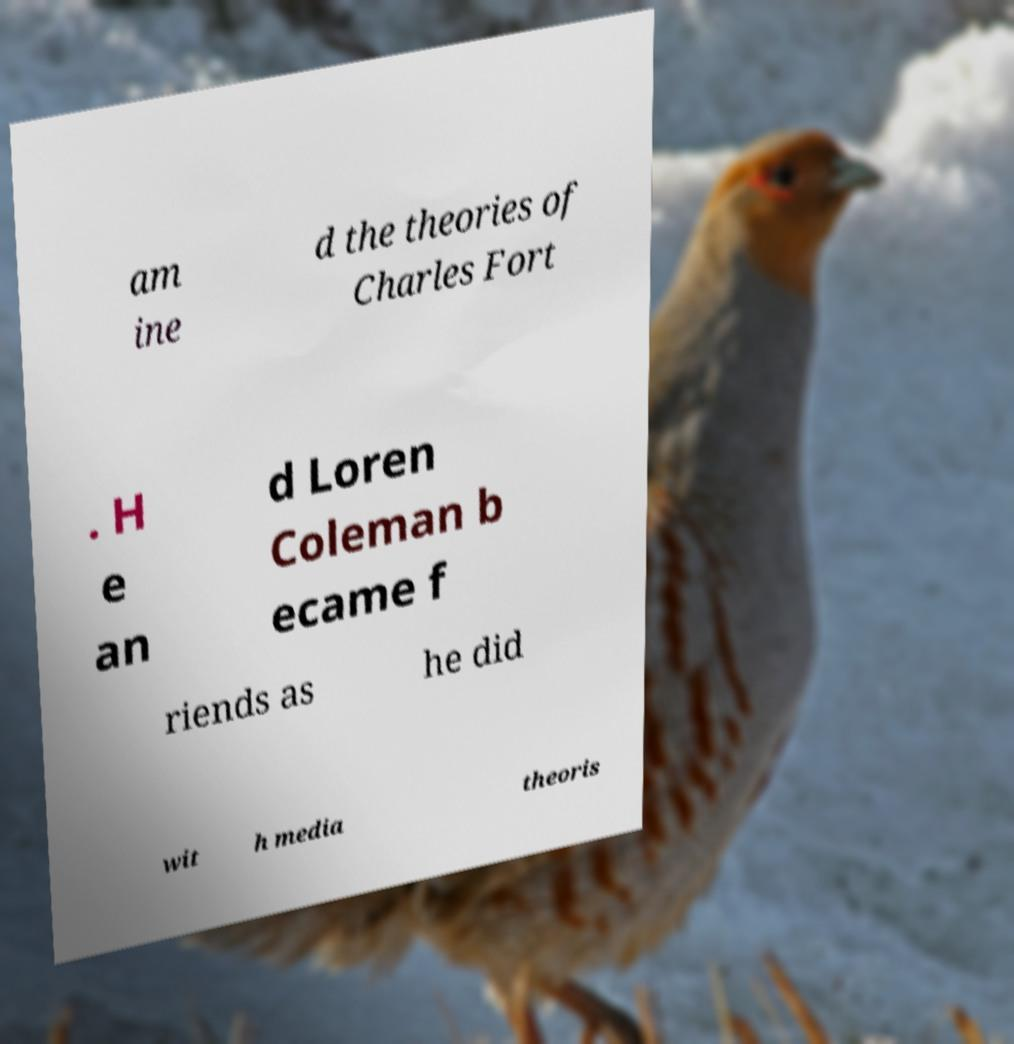For documentation purposes, I need the text within this image transcribed. Could you provide that? am ine d the theories of Charles Fort . H e an d Loren Coleman b ecame f riends as he did wit h media theoris 